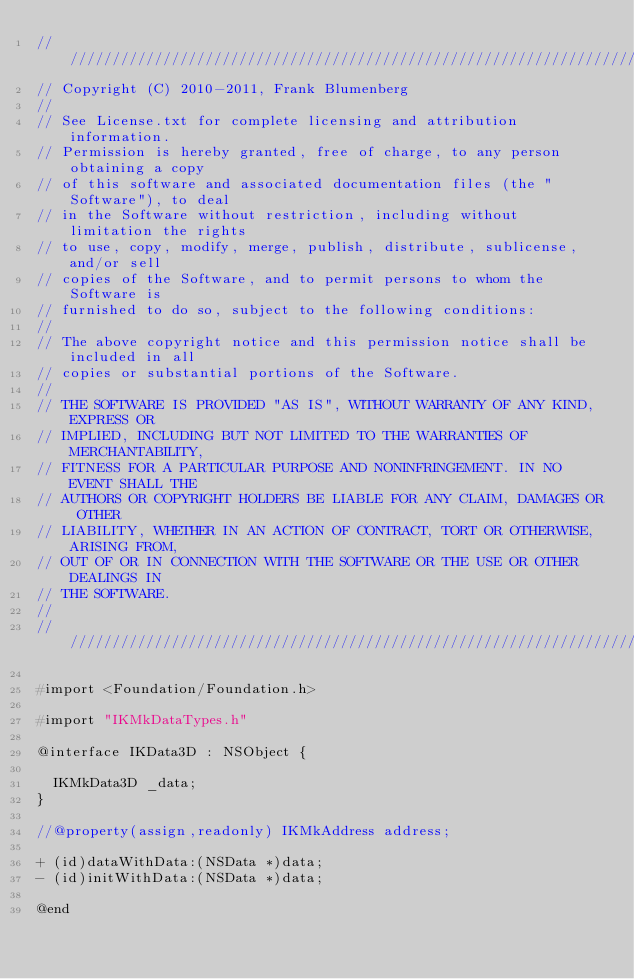<code> <loc_0><loc_0><loc_500><loc_500><_C_>// ///////////////////////////////////////////////////////////////////////////////
// Copyright (C) 2010-2011, Frank Blumenberg
//
// See License.txt for complete licensing and attribution information.
// Permission is hereby granted, free of charge, to any person obtaining a copy
// of this software and associated documentation files (the "Software"), to deal
// in the Software without restriction, including without limitation the rights
// to use, copy, modify, merge, publish, distribute, sublicense, and/or sell
// copies of the Software, and to permit persons to whom the Software is
// furnished to do so, subject to the following conditions:
//
// The above copyright notice and this permission notice shall be included in all
// copies or substantial portions of the Software.
//
// THE SOFTWARE IS PROVIDED "AS IS", WITHOUT WARRANTY OF ANY KIND, EXPRESS OR
// IMPLIED, INCLUDING BUT NOT LIMITED TO THE WARRANTIES OF MERCHANTABILITY,
// FITNESS FOR A PARTICULAR PURPOSE AND NONINFRINGEMENT. IN NO EVENT SHALL THE
// AUTHORS OR COPYRIGHT HOLDERS BE LIABLE FOR ANY CLAIM, DAMAGES OR OTHER
// LIABILITY, WHETHER IN AN ACTION OF CONTRACT, TORT OR OTHERWISE, ARISING FROM,
// OUT OF OR IN CONNECTION WITH THE SOFTWARE OR THE USE OR OTHER DEALINGS IN
// THE SOFTWARE.
//
// ///////////////////////////////////////////////////////////////////////////////

#import <Foundation/Foundation.h>

#import "IKMkDataTypes.h"

@interface IKData3D : NSObject {

  IKMkData3D _data;
}

//@property(assign,readonly) IKMkAddress address;

+ (id)dataWithData:(NSData *)data;
- (id)initWithData:(NSData *)data;

@end
</code> 